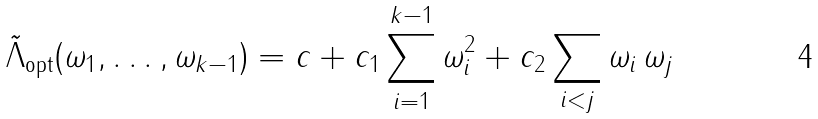<formula> <loc_0><loc_0><loc_500><loc_500>\tilde { \Lambda } _ { \text {opt} } ( \omega _ { 1 } , \dots , \omega _ { k - 1 } ) = c + c _ { 1 } \sum _ { i = 1 } ^ { k - 1 } \omega _ { i } ^ { 2 } + c _ { 2 } \sum _ { i < j } \omega _ { i } \, \omega _ { j }</formula> 